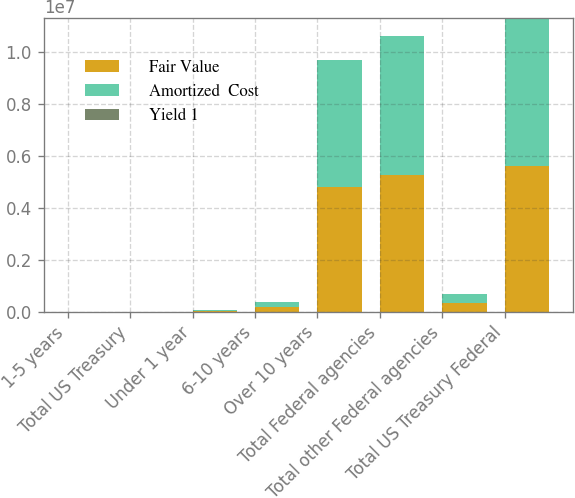Convert chart to OTSL. <chart><loc_0><loc_0><loc_500><loc_500><stacked_bar_chart><ecel><fcel>1-5 years<fcel>Total US Treasury<fcel>Under 1 year<fcel>6-10 years<fcel>Over 10 years<fcel>Total Federal agencies<fcel>Total other Federal agencies<fcel>Total US Treasury Federal<nl><fcel>Fair Value<fcel>5435<fcel>5435<fcel>47023<fcel>184576<fcel>4.82552e+06<fcel>5.2739e+06<fcel>349715<fcel>5.62905e+06<nl><fcel>Amortized  Cost<fcel>5452<fcel>5452<fcel>47190<fcel>186938<fcel>4.8675e+06<fcel>5.3227e+06<fcel>351543<fcel>5.6797e+06<nl><fcel>Yield 1<fcel>1.2<fcel>1.2<fcel>1.99<fcel>2.87<fcel>2.42<fcel>2.43<fcel>2.51<fcel>2.43<nl></chart> 